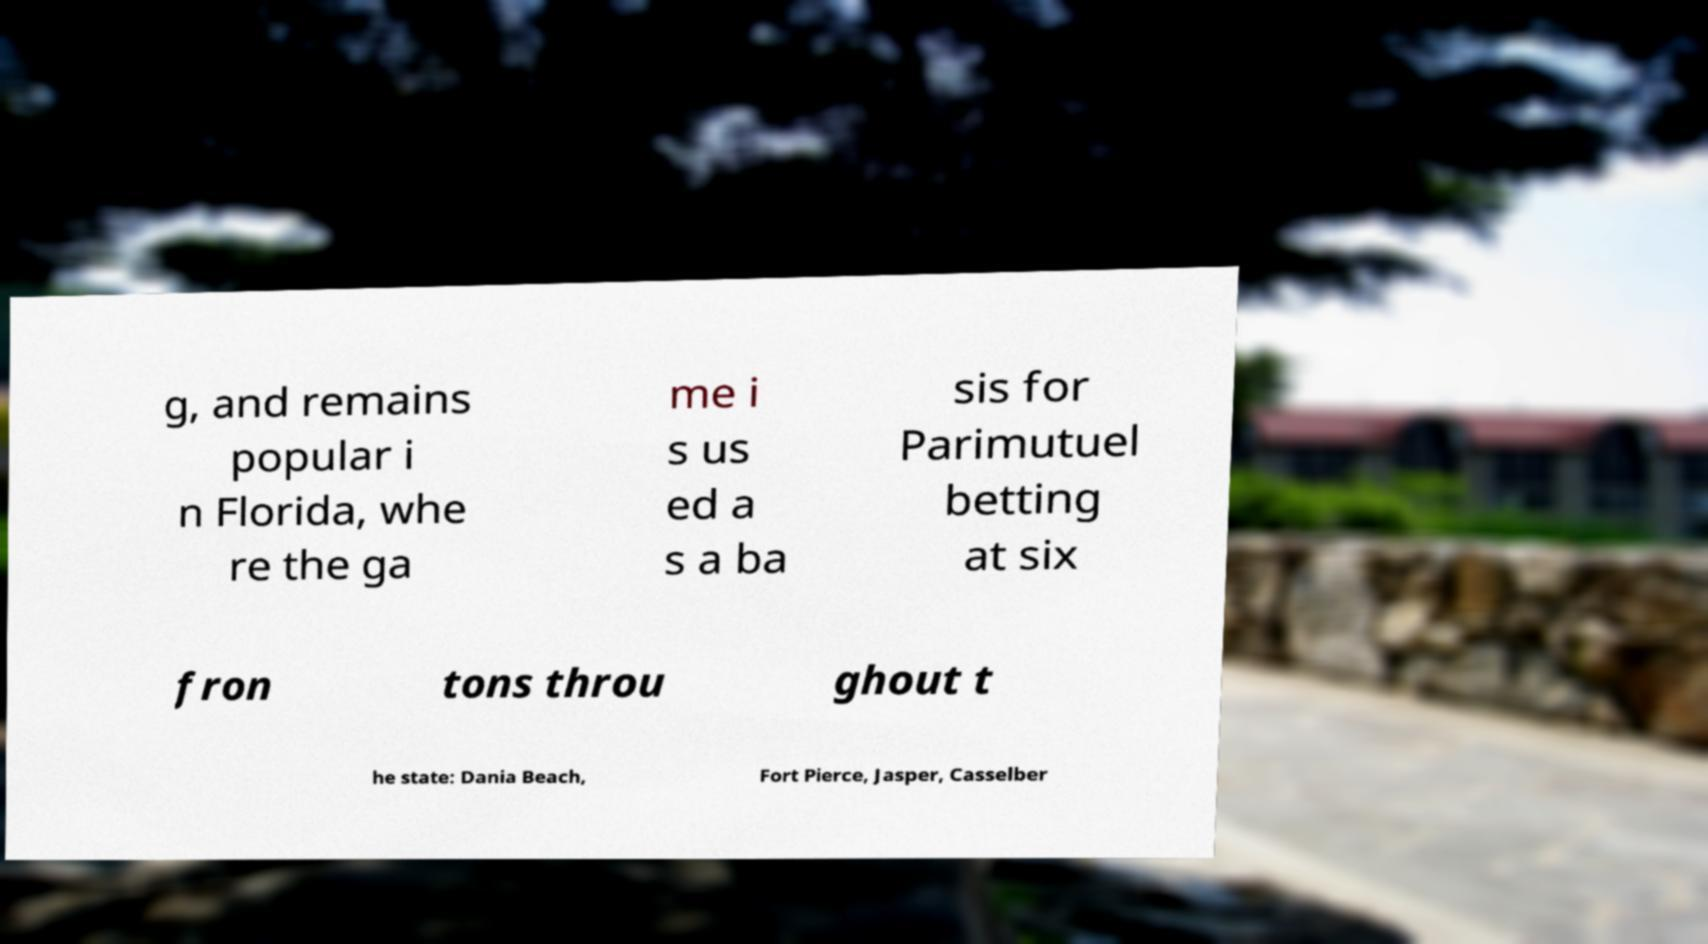There's text embedded in this image that I need extracted. Can you transcribe it verbatim? g, and remains popular i n Florida, whe re the ga me i s us ed a s a ba sis for Parimutuel betting at six fron tons throu ghout t he state: Dania Beach, Fort Pierce, Jasper, Casselber 